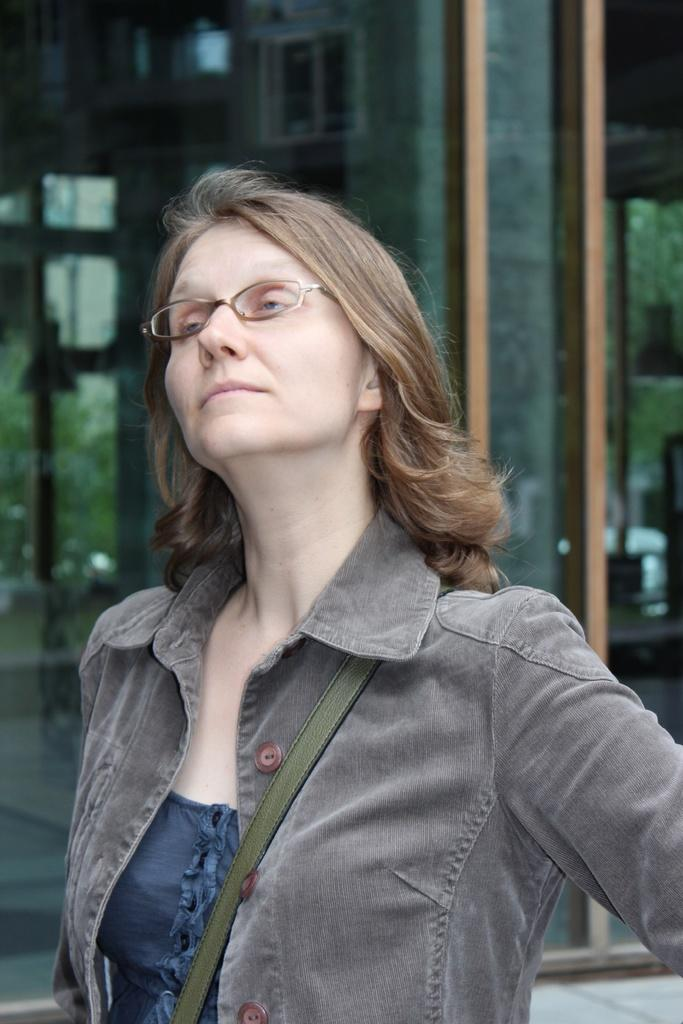What is the main subject of the image? There is a beautiful woman in the image. What is the woman wearing in the image? The woman is wearing a coat and spectacles. What can be seen behind the woman in the image? There are glass walls behind the woman. How does the woman help the sleet in the image? There is no sleet present in the image, so the woman cannot help it. 